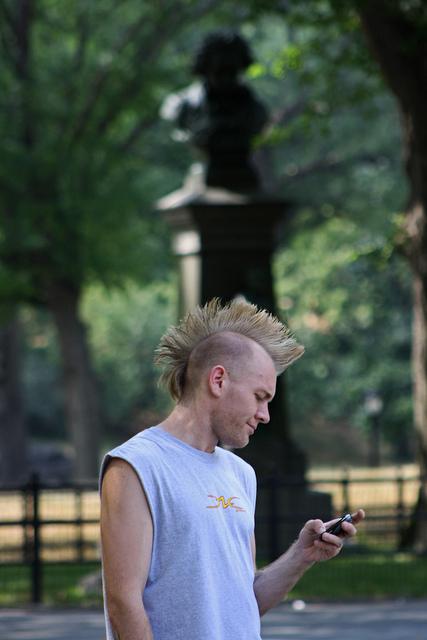What is the man doing holding a cell phone?
Write a very short answer. Texting. Is the temperature hot?
Short answer required. Yes. Which hand is the phone in?
Short answer required. Left. What is the hairstyle?
Keep it brief. Mohawk. Is the man at a tennis center?
Write a very short answer. No. 